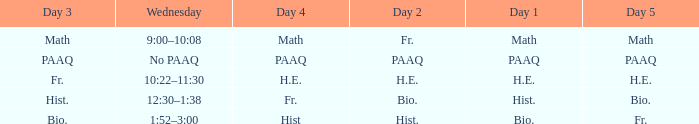Help me parse the entirety of this table. {'header': ['Day 3', 'Wednesday', 'Day 4', 'Day 2', 'Day 1', 'Day 5'], 'rows': [['Math', '9:00–10:08', 'Math', 'Fr.', 'Math', 'Math'], ['PAAQ', 'No PAAQ', 'PAAQ', 'PAAQ', 'PAAQ', 'PAAQ'], ['Fr.', '10:22–11:30', 'H.E.', 'H.E.', 'H.E.', 'H.E.'], ['Hist.', '12:30–1:38', 'Fr.', 'Bio.', 'Hist.', 'Bio.'], ['Bio.', '1:52–3:00', 'Hist', 'Hist.', 'Bio.', 'Fr.']]} What is the day 1 when the day 3 is math? Math. 